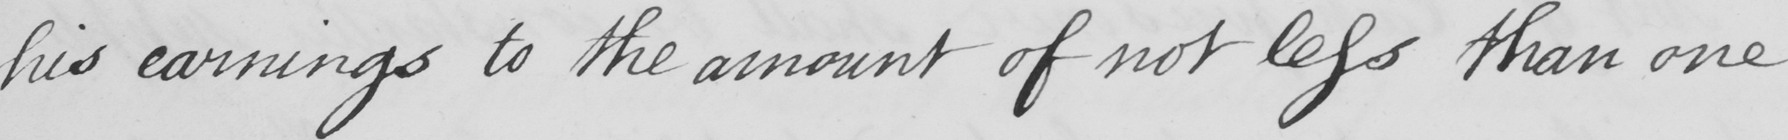Can you tell me what this handwritten text says? his earnings to the amount of not less than one 